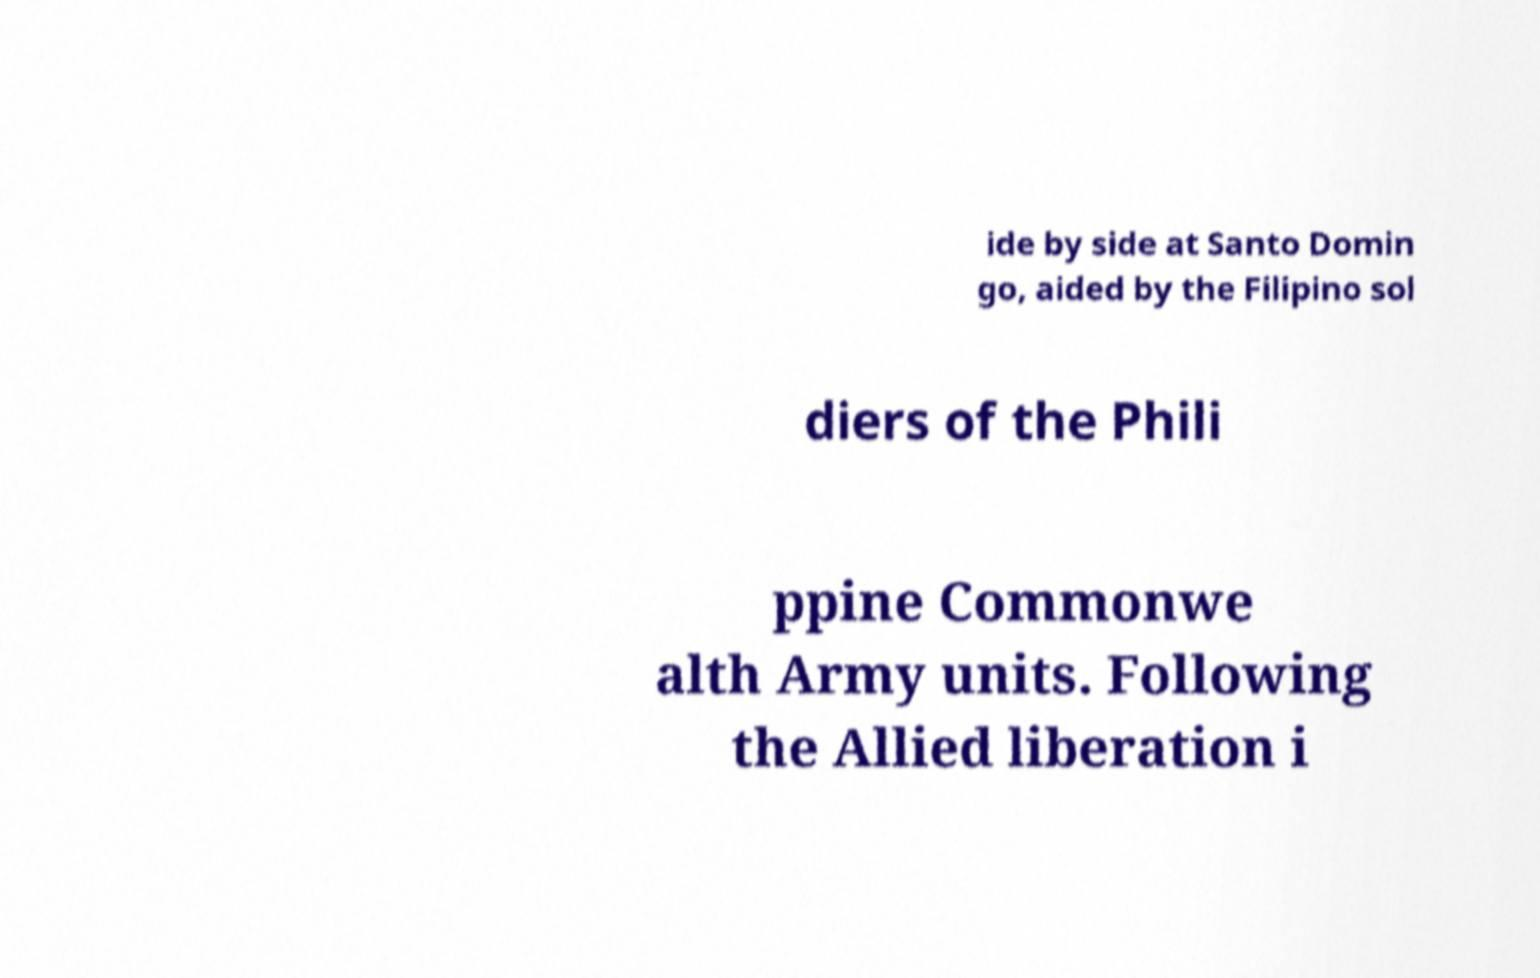There's text embedded in this image that I need extracted. Can you transcribe it verbatim? ide by side at Santo Domin go, aided by the Filipino sol diers of the Phili ppine Commonwe alth Army units. Following the Allied liberation i 